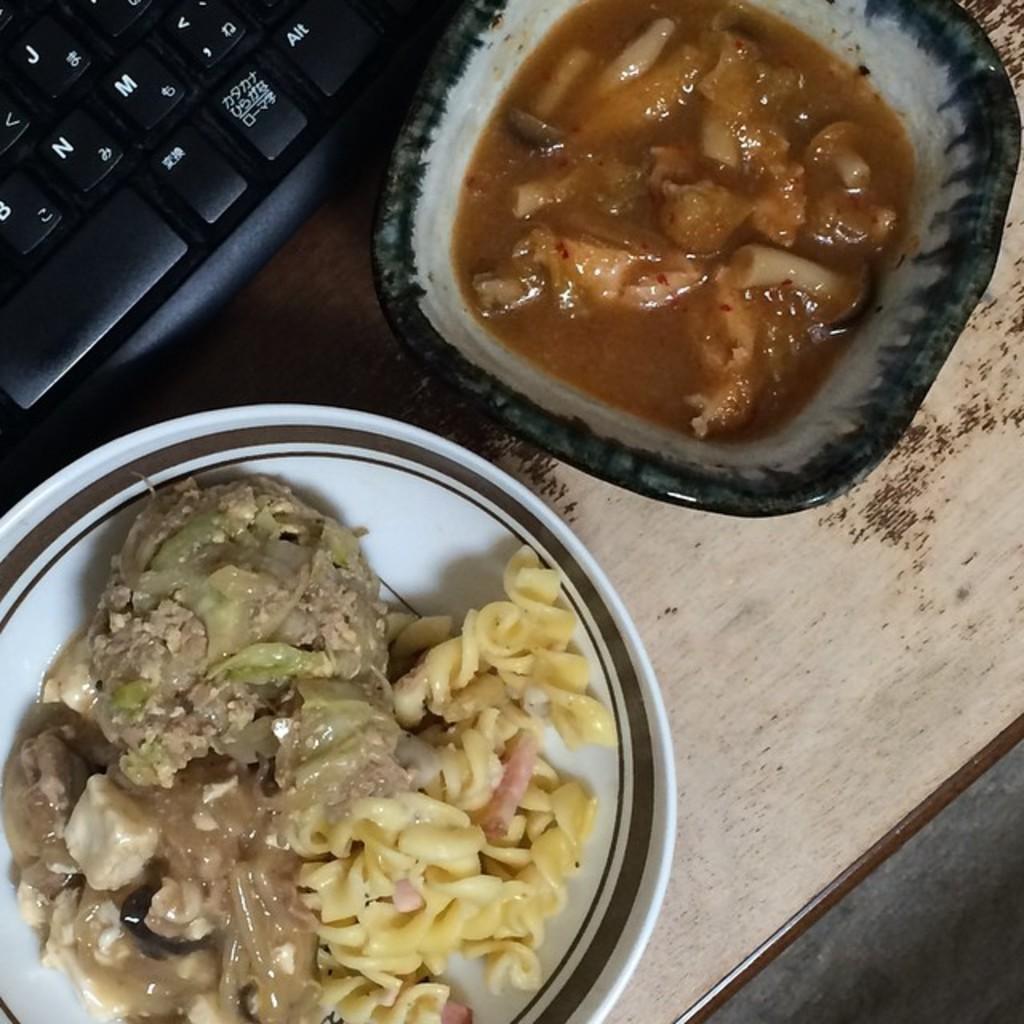Please provide a concise description of this image. In this image I can see a keyboard and food items in bowls. These objects are on a wooden surface. 